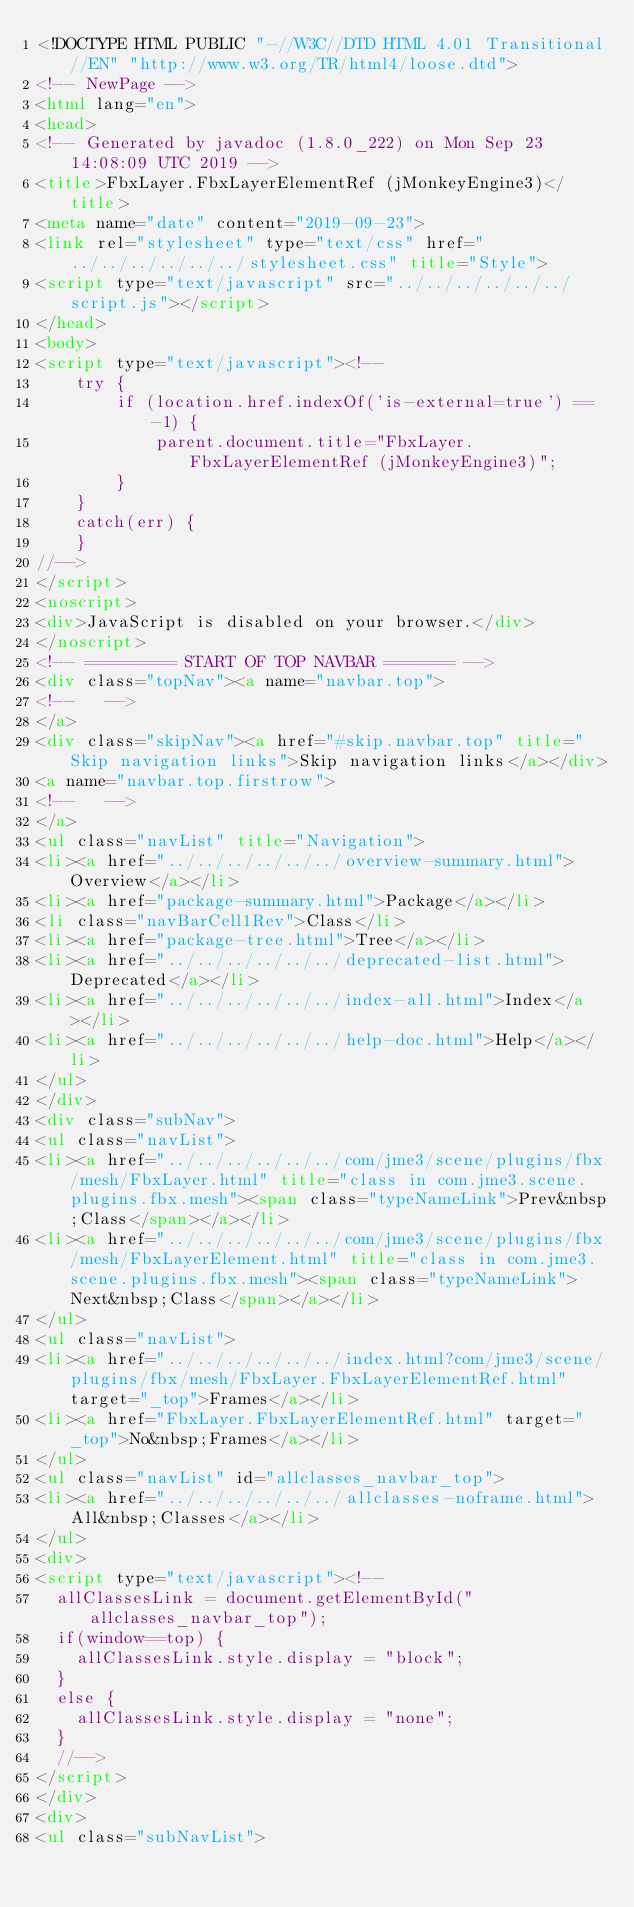<code> <loc_0><loc_0><loc_500><loc_500><_HTML_><!DOCTYPE HTML PUBLIC "-//W3C//DTD HTML 4.01 Transitional//EN" "http://www.w3.org/TR/html4/loose.dtd">
<!-- NewPage -->
<html lang="en">
<head>
<!-- Generated by javadoc (1.8.0_222) on Mon Sep 23 14:08:09 UTC 2019 -->
<title>FbxLayer.FbxLayerElementRef (jMonkeyEngine3)</title>
<meta name="date" content="2019-09-23">
<link rel="stylesheet" type="text/css" href="../../../../../../stylesheet.css" title="Style">
<script type="text/javascript" src="../../../../../../script.js"></script>
</head>
<body>
<script type="text/javascript"><!--
    try {
        if (location.href.indexOf('is-external=true') == -1) {
            parent.document.title="FbxLayer.FbxLayerElementRef (jMonkeyEngine3)";
        }
    }
    catch(err) {
    }
//-->
</script>
<noscript>
<div>JavaScript is disabled on your browser.</div>
</noscript>
<!-- ========= START OF TOP NAVBAR ======= -->
<div class="topNav"><a name="navbar.top">
<!--   -->
</a>
<div class="skipNav"><a href="#skip.navbar.top" title="Skip navigation links">Skip navigation links</a></div>
<a name="navbar.top.firstrow">
<!--   -->
</a>
<ul class="navList" title="Navigation">
<li><a href="../../../../../../overview-summary.html">Overview</a></li>
<li><a href="package-summary.html">Package</a></li>
<li class="navBarCell1Rev">Class</li>
<li><a href="package-tree.html">Tree</a></li>
<li><a href="../../../../../../deprecated-list.html">Deprecated</a></li>
<li><a href="../../../../../../index-all.html">Index</a></li>
<li><a href="../../../../../../help-doc.html">Help</a></li>
</ul>
</div>
<div class="subNav">
<ul class="navList">
<li><a href="../../../../../../com/jme3/scene/plugins/fbx/mesh/FbxLayer.html" title="class in com.jme3.scene.plugins.fbx.mesh"><span class="typeNameLink">Prev&nbsp;Class</span></a></li>
<li><a href="../../../../../../com/jme3/scene/plugins/fbx/mesh/FbxLayerElement.html" title="class in com.jme3.scene.plugins.fbx.mesh"><span class="typeNameLink">Next&nbsp;Class</span></a></li>
</ul>
<ul class="navList">
<li><a href="../../../../../../index.html?com/jme3/scene/plugins/fbx/mesh/FbxLayer.FbxLayerElementRef.html" target="_top">Frames</a></li>
<li><a href="FbxLayer.FbxLayerElementRef.html" target="_top">No&nbsp;Frames</a></li>
</ul>
<ul class="navList" id="allclasses_navbar_top">
<li><a href="../../../../../../allclasses-noframe.html">All&nbsp;Classes</a></li>
</ul>
<div>
<script type="text/javascript"><!--
  allClassesLink = document.getElementById("allclasses_navbar_top");
  if(window==top) {
    allClassesLink.style.display = "block";
  }
  else {
    allClassesLink.style.display = "none";
  }
  //-->
</script>
</div>
<div>
<ul class="subNavList"></code> 